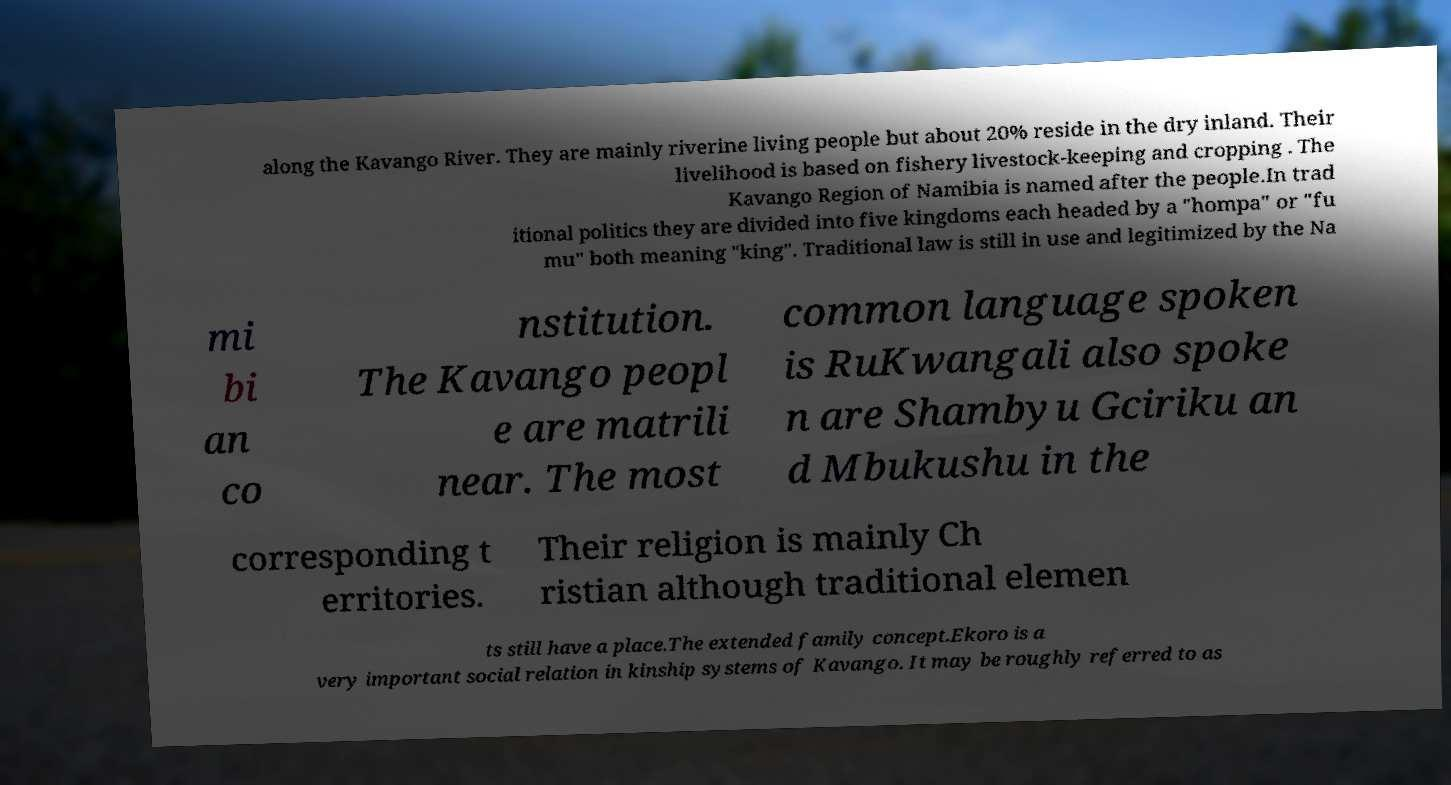What messages or text are displayed in this image? I need them in a readable, typed format. along the Kavango River. They are mainly riverine living people but about 20% reside in the dry inland. Their livelihood is based on fishery livestock-keeping and cropping . The Kavango Region of Namibia is named after the people.In trad itional politics they are divided into five kingdoms each headed by a "hompa" or "fu mu" both meaning "king". Traditional law is still in use and legitimized by the Na mi bi an co nstitution. The Kavango peopl e are matrili near. The most common language spoken is RuKwangali also spoke n are Shambyu Gciriku an d Mbukushu in the corresponding t erritories. Their religion is mainly Ch ristian although traditional elemen ts still have a place.The extended family concept.Ekoro is a very important social relation in kinship systems of Kavango. It may be roughly referred to as 